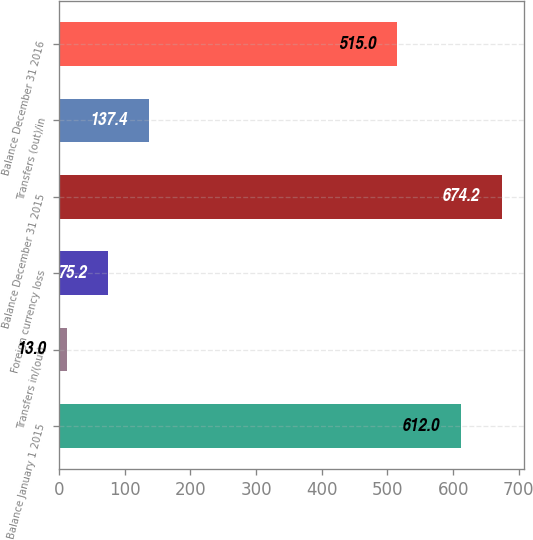Convert chart. <chart><loc_0><loc_0><loc_500><loc_500><bar_chart><fcel>Balance January 1 2015<fcel>Transfers in/(out)<fcel>Foreign currency loss<fcel>Balance December 31 2015<fcel>Transfers (out)/in<fcel>Balance December 31 2016<nl><fcel>612<fcel>13<fcel>75.2<fcel>674.2<fcel>137.4<fcel>515<nl></chart> 